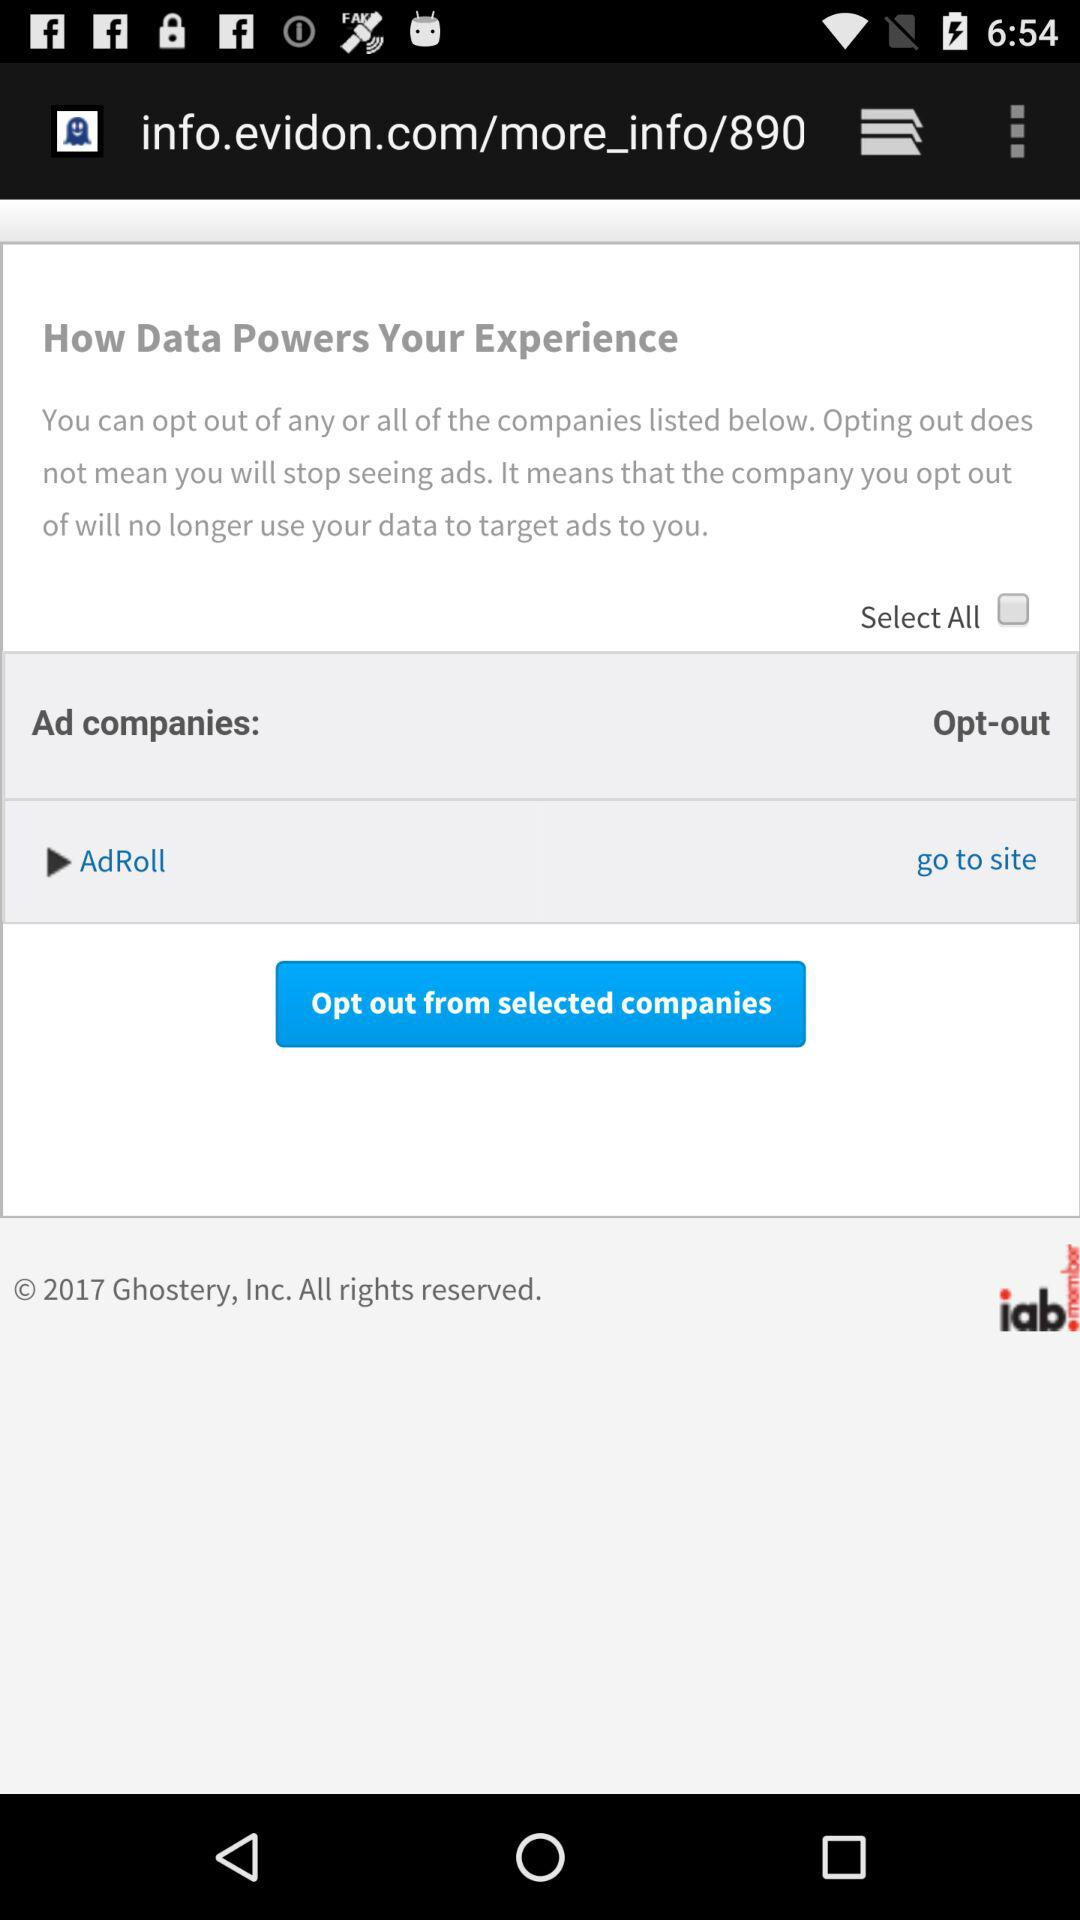Is "Select All" checked or unchecked?
Answer the question using a single word or phrase. It is unchecked. 